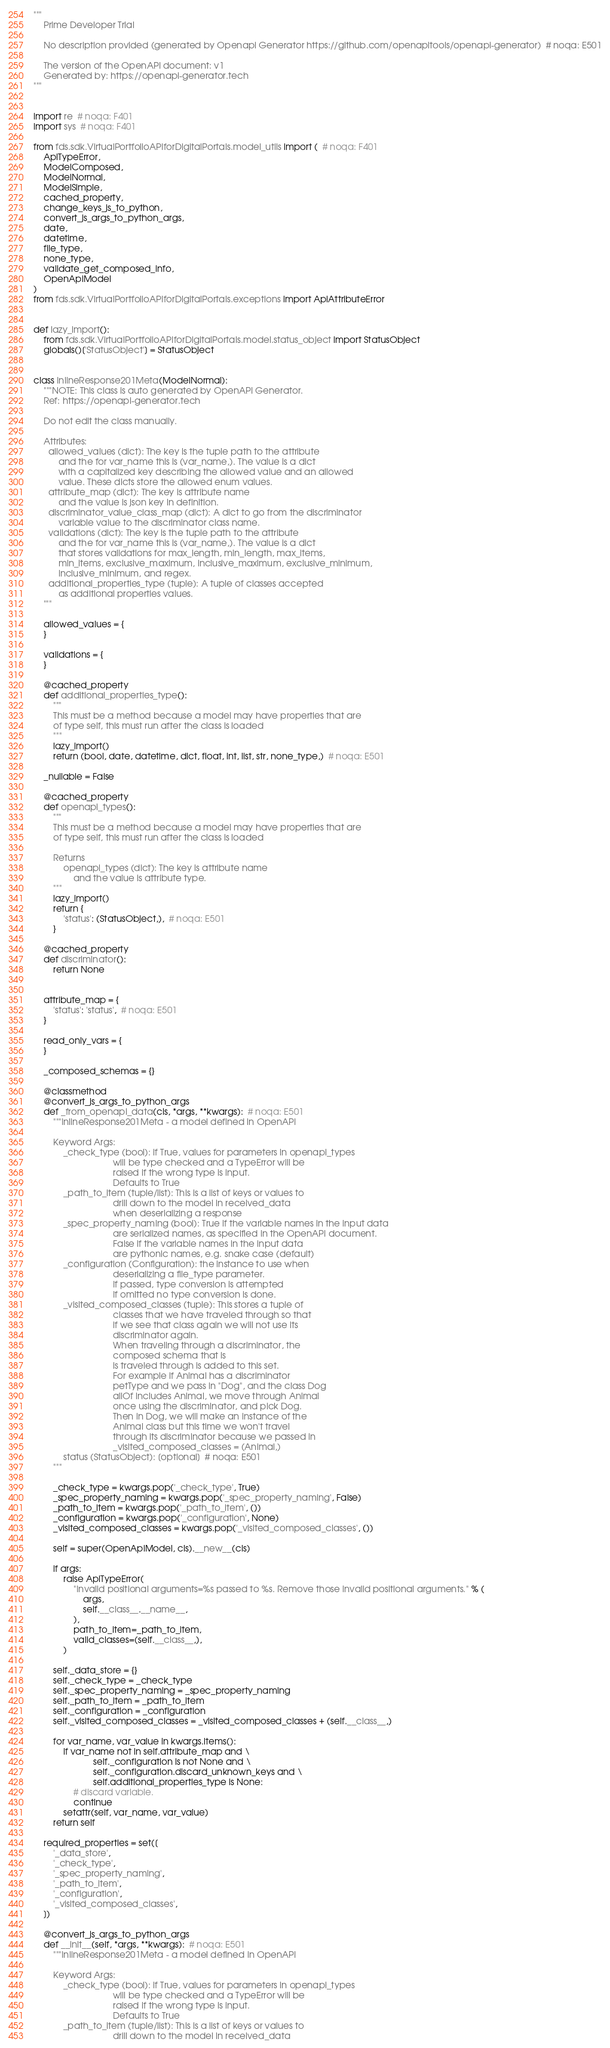Convert code to text. <code><loc_0><loc_0><loc_500><loc_500><_Python_>"""
    Prime Developer Trial

    No description provided (generated by Openapi Generator https://github.com/openapitools/openapi-generator)  # noqa: E501

    The version of the OpenAPI document: v1
    Generated by: https://openapi-generator.tech
"""


import re  # noqa: F401
import sys  # noqa: F401

from fds.sdk.VirtualPortfolioAPIforDigitalPortals.model_utils import (  # noqa: F401
    ApiTypeError,
    ModelComposed,
    ModelNormal,
    ModelSimple,
    cached_property,
    change_keys_js_to_python,
    convert_js_args_to_python_args,
    date,
    datetime,
    file_type,
    none_type,
    validate_get_composed_info,
    OpenApiModel
)
from fds.sdk.VirtualPortfolioAPIforDigitalPortals.exceptions import ApiAttributeError


def lazy_import():
    from fds.sdk.VirtualPortfolioAPIforDigitalPortals.model.status_object import StatusObject
    globals()['StatusObject'] = StatusObject


class InlineResponse201Meta(ModelNormal):
    """NOTE: This class is auto generated by OpenAPI Generator.
    Ref: https://openapi-generator.tech

    Do not edit the class manually.

    Attributes:
      allowed_values (dict): The key is the tuple path to the attribute
          and the for var_name this is (var_name,). The value is a dict
          with a capitalized key describing the allowed value and an allowed
          value. These dicts store the allowed enum values.
      attribute_map (dict): The key is attribute name
          and the value is json key in definition.
      discriminator_value_class_map (dict): A dict to go from the discriminator
          variable value to the discriminator class name.
      validations (dict): The key is the tuple path to the attribute
          and the for var_name this is (var_name,). The value is a dict
          that stores validations for max_length, min_length, max_items,
          min_items, exclusive_maximum, inclusive_maximum, exclusive_minimum,
          inclusive_minimum, and regex.
      additional_properties_type (tuple): A tuple of classes accepted
          as additional properties values.
    """

    allowed_values = {
    }

    validations = {
    }

    @cached_property
    def additional_properties_type():
        """
        This must be a method because a model may have properties that are
        of type self, this must run after the class is loaded
        """
        lazy_import()
        return (bool, date, datetime, dict, float, int, list, str, none_type,)  # noqa: E501

    _nullable = False

    @cached_property
    def openapi_types():
        """
        This must be a method because a model may have properties that are
        of type self, this must run after the class is loaded

        Returns
            openapi_types (dict): The key is attribute name
                and the value is attribute type.
        """
        lazy_import()
        return {
            'status': (StatusObject,),  # noqa: E501
        }

    @cached_property
    def discriminator():
        return None


    attribute_map = {
        'status': 'status',  # noqa: E501
    }

    read_only_vars = {
    }

    _composed_schemas = {}

    @classmethod
    @convert_js_args_to_python_args
    def _from_openapi_data(cls, *args, **kwargs):  # noqa: E501
        """InlineResponse201Meta - a model defined in OpenAPI

        Keyword Args:
            _check_type (bool): if True, values for parameters in openapi_types
                                will be type checked and a TypeError will be
                                raised if the wrong type is input.
                                Defaults to True
            _path_to_item (tuple/list): This is a list of keys or values to
                                drill down to the model in received_data
                                when deserializing a response
            _spec_property_naming (bool): True if the variable names in the input data
                                are serialized names, as specified in the OpenAPI document.
                                False if the variable names in the input data
                                are pythonic names, e.g. snake case (default)
            _configuration (Configuration): the instance to use when
                                deserializing a file_type parameter.
                                If passed, type conversion is attempted
                                If omitted no type conversion is done.
            _visited_composed_classes (tuple): This stores a tuple of
                                classes that we have traveled through so that
                                if we see that class again we will not use its
                                discriminator again.
                                When traveling through a discriminator, the
                                composed schema that is
                                is traveled through is added to this set.
                                For example if Animal has a discriminator
                                petType and we pass in "Dog", and the class Dog
                                allOf includes Animal, we move through Animal
                                once using the discriminator, and pick Dog.
                                Then in Dog, we will make an instance of the
                                Animal class but this time we won't travel
                                through its discriminator because we passed in
                                _visited_composed_classes = (Animal,)
            status (StatusObject): [optional]  # noqa: E501
        """

        _check_type = kwargs.pop('_check_type', True)
        _spec_property_naming = kwargs.pop('_spec_property_naming', False)
        _path_to_item = kwargs.pop('_path_to_item', ())
        _configuration = kwargs.pop('_configuration', None)
        _visited_composed_classes = kwargs.pop('_visited_composed_classes', ())

        self = super(OpenApiModel, cls).__new__(cls)

        if args:
            raise ApiTypeError(
                "Invalid positional arguments=%s passed to %s. Remove those invalid positional arguments." % (
                    args,
                    self.__class__.__name__,
                ),
                path_to_item=_path_to_item,
                valid_classes=(self.__class__,),
            )

        self._data_store = {}
        self._check_type = _check_type
        self._spec_property_naming = _spec_property_naming
        self._path_to_item = _path_to_item
        self._configuration = _configuration
        self._visited_composed_classes = _visited_composed_classes + (self.__class__,)

        for var_name, var_value in kwargs.items():
            if var_name not in self.attribute_map and \
                        self._configuration is not None and \
                        self._configuration.discard_unknown_keys and \
                        self.additional_properties_type is None:
                # discard variable.
                continue
            setattr(self, var_name, var_value)
        return self

    required_properties = set([
        '_data_store',
        '_check_type',
        '_spec_property_naming',
        '_path_to_item',
        '_configuration',
        '_visited_composed_classes',
    ])

    @convert_js_args_to_python_args
    def __init__(self, *args, **kwargs):  # noqa: E501
        """InlineResponse201Meta - a model defined in OpenAPI

        Keyword Args:
            _check_type (bool): if True, values for parameters in openapi_types
                                will be type checked and a TypeError will be
                                raised if the wrong type is input.
                                Defaults to True
            _path_to_item (tuple/list): This is a list of keys or values to
                                drill down to the model in received_data</code> 